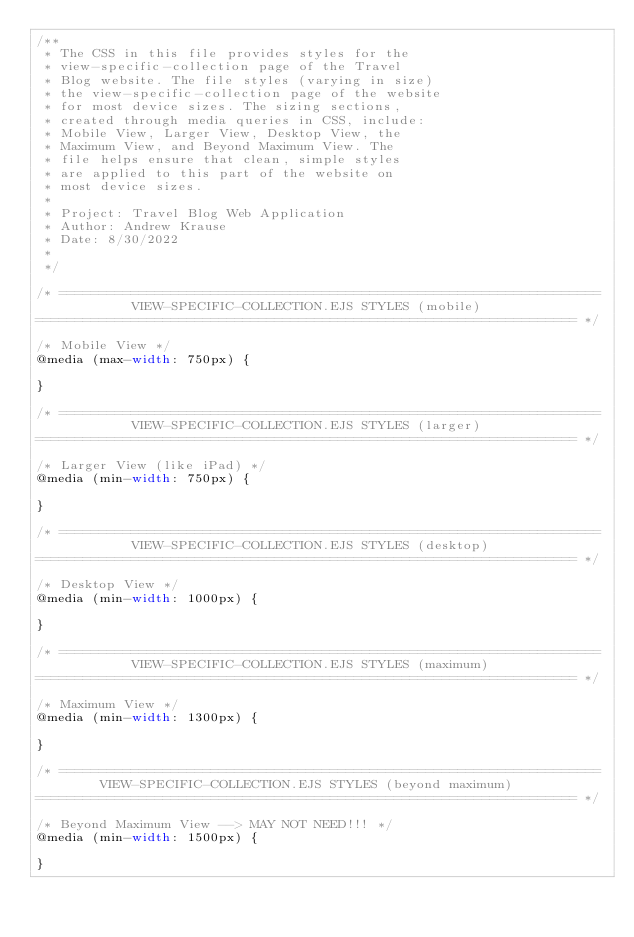<code> <loc_0><loc_0><loc_500><loc_500><_CSS_>/**
 * The CSS in this file provides styles for the
 * view-specific-collection page of the Travel 
 * Blog website. The file styles (varying in size)
 * the view-specific-collection page of the website
 * for most device sizes. The sizing sections,
 * created through media queries in CSS, include: 
 * Mobile View, Larger View, Desktop View, the 
 * Maximum View, and Beyond Maximum View. The 
 * file helps ensure that clean, simple styles 
 * are applied to this part of the website on 
 * most device sizes.
 *
 * Project: Travel Blog Web Application
 * Author: Andrew Krause
 * Date: 8/30/2022
 *
 */

/* ====================================================================
            VIEW-SPECIFIC-COLLECTION.EJS STYLES (mobile)
==================================================================== */

/* Mobile View */
@media (max-width: 750px) {

}

/* ====================================================================
            VIEW-SPECIFIC-COLLECTION.EJS STYLES (larger)
==================================================================== */

/* Larger View (like iPad) */
@media (min-width: 750px) {

}

/* ====================================================================
            VIEW-SPECIFIC-COLLECTION.EJS STYLES (desktop)
==================================================================== */

/* Desktop View */    
@media (min-width: 1000px) {

}

/* ====================================================================
            VIEW-SPECIFIC-COLLECTION.EJS STYLES (maximum)
==================================================================== */

/* Maximum View */    
@media (min-width: 1300px) {

}

/* ====================================================================
        VIEW-SPECIFIC-COLLECTION.EJS STYLES (beyond maximum)
==================================================================== */

/* Beyond Maximum View --> MAY NOT NEED!!! */    
@media (min-width: 1500px) {

}</code> 